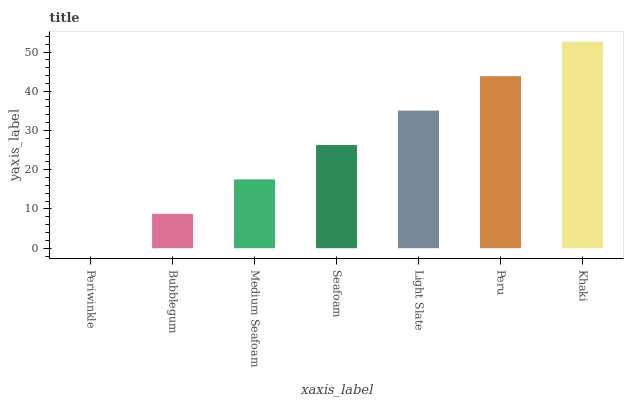Is Periwinkle the minimum?
Answer yes or no. Yes. Is Khaki the maximum?
Answer yes or no. Yes. Is Bubblegum the minimum?
Answer yes or no. No. Is Bubblegum the maximum?
Answer yes or no. No. Is Bubblegum greater than Periwinkle?
Answer yes or no. Yes. Is Periwinkle less than Bubblegum?
Answer yes or no. Yes. Is Periwinkle greater than Bubblegum?
Answer yes or no. No. Is Bubblegum less than Periwinkle?
Answer yes or no. No. Is Seafoam the high median?
Answer yes or no. Yes. Is Seafoam the low median?
Answer yes or no. Yes. Is Khaki the high median?
Answer yes or no. No. Is Bubblegum the low median?
Answer yes or no. No. 